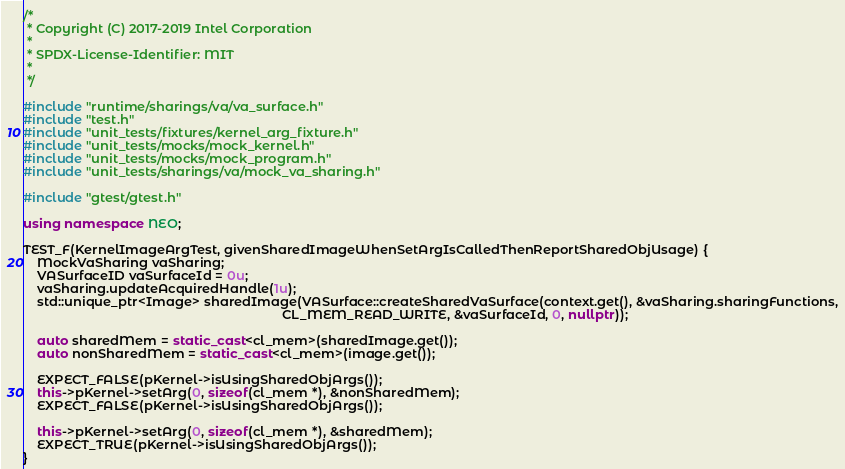<code> <loc_0><loc_0><loc_500><loc_500><_C++_>/*
 * Copyright (C) 2017-2019 Intel Corporation
 *
 * SPDX-License-Identifier: MIT
 *
 */

#include "runtime/sharings/va/va_surface.h"
#include "test.h"
#include "unit_tests/fixtures/kernel_arg_fixture.h"
#include "unit_tests/mocks/mock_kernel.h"
#include "unit_tests/mocks/mock_program.h"
#include "unit_tests/sharings/va/mock_va_sharing.h"

#include "gtest/gtest.h"

using namespace NEO;

TEST_F(KernelImageArgTest, givenSharedImageWhenSetArgIsCalledThenReportSharedObjUsage) {
    MockVaSharing vaSharing;
    VASurfaceID vaSurfaceId = 0u;
    vaSharing.updateAcquiredHandle(1u);
    std::unique_ptr<Image> sharedImage(VASurface::createSharedVaSurface(context.get(), &vaSharing.sharingFunctions,
                                                                        CL_MEM_READ_WRITE, &vaSurfaceId, 0, nullptr));

    auto sharedMem = static_cast<cl_mem>(sharedImage.get());
    auto nonSharedMem = static_cast<cl_mem>(image.get());

    EXPECT_FALSE(pKernel->isUsingSharedObjArgs());
    this->pKernel->setArg(0, sizeof(cl_mem *), &nonSharedMem);
    EXPECT_FALSE(pKernel->isUsingSharedObjArgs());

    this->pKernel->setArg(0, sizeof(cl_mem *), &sharedMem);
    EXPECT_TRUE(pKernel->isUsingSharedObjArgs());
}
</code> 